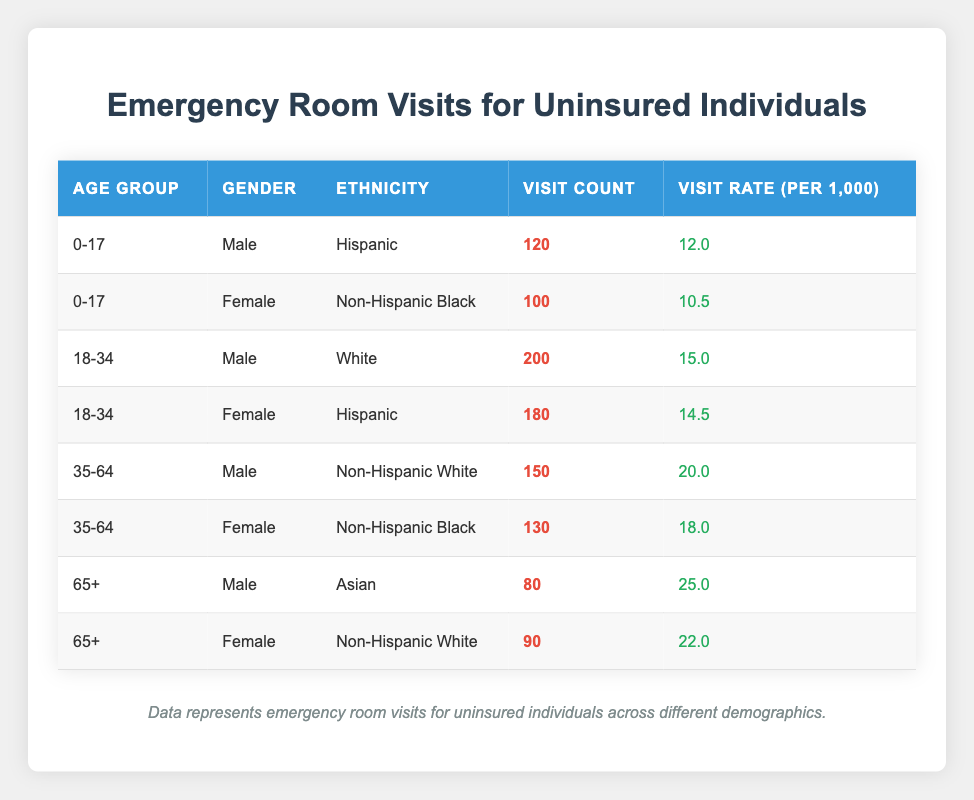What is the visit count for uninsured females aged 0-17? From the table, we can find the row for females in the age group 0-17. The visit count for this group is listed as 100.
Answer: 100 How many emergency room visits were there for uninsured males aged 35-64? Looking at the table, the visit count for uninsured males in the 35-64 age group is 150.
Answer: 150 What is the total visit count for uninsured individuals aged 18-34? We need to consider the visit counts for both males and females in this age group: 200 (males) + 180 (females) = 380.
Answer: 380 Which age group has the highest visit rate per 1,000 for uninsured individuals? Evaluating the visit rates from the table: 12.0 (0-17), 15.0 (18-34), 20.0 (35-64), and 25.0 (65+). The highest rate is 25.0 in the 65+ age group.
Answer: 65+ Is it true that the visit count for Hispanic individuals aged 18-34 is greater than the visit count for Non-Hispanic Black individuals aged 35-64? The visit count for Hispanic females aged 18-34 is 180, while for Non-Hispanic Black females aged 35-64, it is 130. Since 180 is greater than 130, the statement is true.
Answer: Yes What is the average visit rate for uninsured individuals across all age groups? To find the average, sum all the visit rates: (12.0 + 10.5 + 15.0 + 14.5 + 20.0 + 18.0 + 25.0 + 22.0) = 127.0. There are 8 groups total, so the average is 127.0 / 8 = 15.875.
Answer: 15.875 How many more visits did uninsured males have than uninsured females in the age group 65+? The visit counts are 80 for males and 90 for females in the 65+ age group. The difference is 90 - 80 = 10, indicating females had more visits.
Answer: 10 Which gender had more emergency room visits among uninsured individuals aged 0-17? For the 0-17 age group, males had 120 visits while females had 100 visits, indicating males had more visits.
Answer: Males What is the total count of emergency room visits for uninsured individuals across all demographics? We need to sum all the visit counts from the table: 120 + 100 + 200 + 180 + 150 + 130 + 80 + 90 = 1,150 total visits.
Answer: 1150 